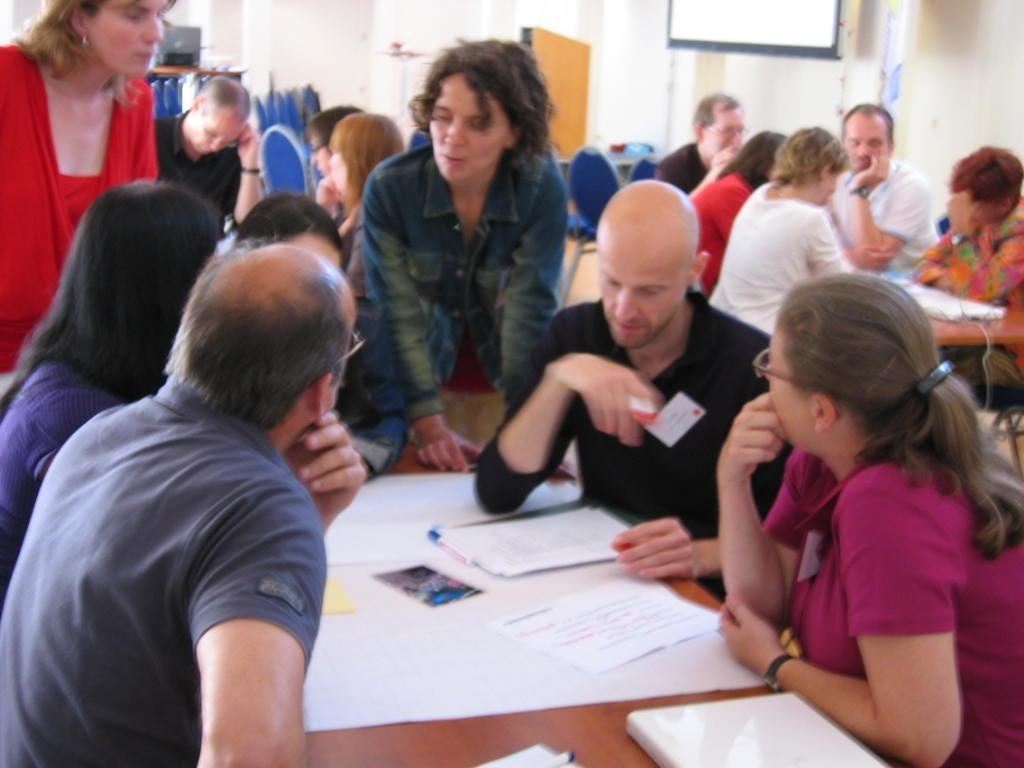Describe this image in one or two sentences. This is the picture of a room. In this image there are group of people sitting and there are two persons standing. There are papers and devices on the table. At the back there is a screen and there are chairs and there is a computer on the table. 